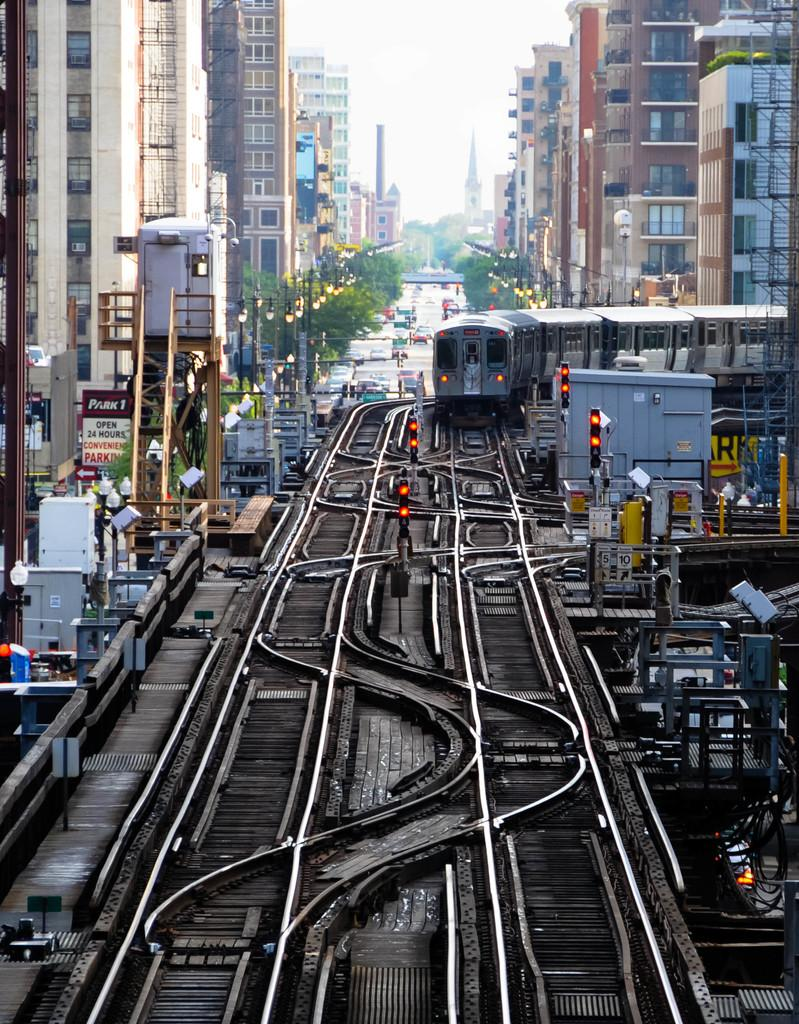What mode of transport can be seen on the railway track in the image? There is a train on the railway track in the image. What can be seen near the railway track to regulate traffic? There are traffic signals in the image. What type of structures are visible in the image? There are buildings and towers in the image. What type of vegetation can be seen in the image? There are trees in the image. What type of infrastructure is present in the image? There are street poles and street lights in the image. What else can be seen on the road in the image? There are motor vehicles on the road in the image. What part of the natural environment is visible in the image? The sky is visible in the image. What type of ink is being used to write on the train in the image? There is no indication in the image that any writing is taking place on the train, so it cannot be determined what type of ink might be used. 